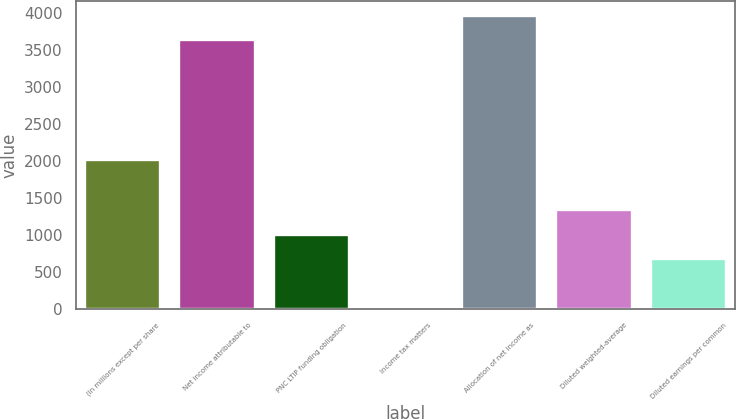Convert chart to OTSL. <chart><loc_0><loc_0><loc_500><loc_500><bar_chart><fcel>(in millions except per share<fcel>Net income attributable to<fcel>PNC LTIP funding obligation<fcel>Income tax matters<fcel>Allocation of net income as<fcel>Diluted weighted-average<fcel>Diluted earnings per common<nl><fcel>2014<fcel>3624.1<fcel>999.3<fcel>9<fcel>3954.2<fcel>1329.4<fcel>669.2<nl></chart> 